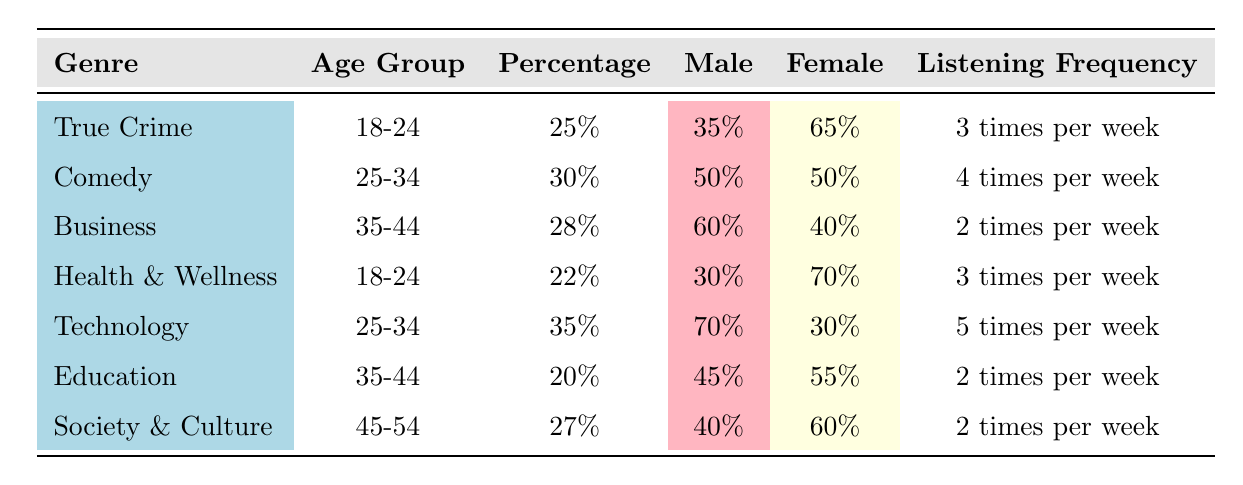What is the percentage of True Crime listeners in the 18-24 age group? The table shows that the genre True Crime has a percentage of 25 in the age group 18-24.
Answer: 25% Which gender has a higher percentage of listeners in the True Crime genre? The gender distribution for True Crime indicates that 35% are male and 65% are female. Therefore, female listeners have a higher percentage.
Answer: Female What is the average listening frequency for the Technology genre? The table states that the average listening frequency for the Technology genre is 5 times per week.
Answer: 5 times per week What percentage of Business listeners are male? The gender distribution for the Business genre indicates that 60% are male.
Answer: 60% If we look at the age group 25-34, what is the average percentage across Comedy and Technology genres? The percentage for Comedy is 30 and for Technology is 35. To find the average, we sum these values (30 + 35 = 65) and divide by 2, yielding an average of 32.5.
Answer: 32.5% Which genre has the lowest percentage of listeners in the 35-44 age group? In the table, Education has a percentage of 20 while Business has a percentage of 28. Since 20 is lower than 28, Education has the lowest percentage in the 35-44 age group.
Answer: Education True or False: The majority of listeners in the Health & Wellness genre are male. The gender distribution for Health & Wellness shows that 30% are male and 70% are female, proving that the majority are female, hence this statement is false.
Answer: False What is the difference in the percentage of listeners between the Technology and Business genres? The Technology genre has a percentage of 35 while the Business genre has a percentage of 28. The difference is calculated as 35 - 28 = 7.
Answer: 7 Which age group has a higher average listening frequency, 18-24 or 35-44? From the table, the average listening frequency for both 18-24 age group genres (True Crime and Health & Wellness) is 3 times per week, and for the 35-44 age group genres (Business, Education) is 2 times per week. Thus, the 18-24 age group has a higher average listening frequency.
Answer: 18-24 age group 